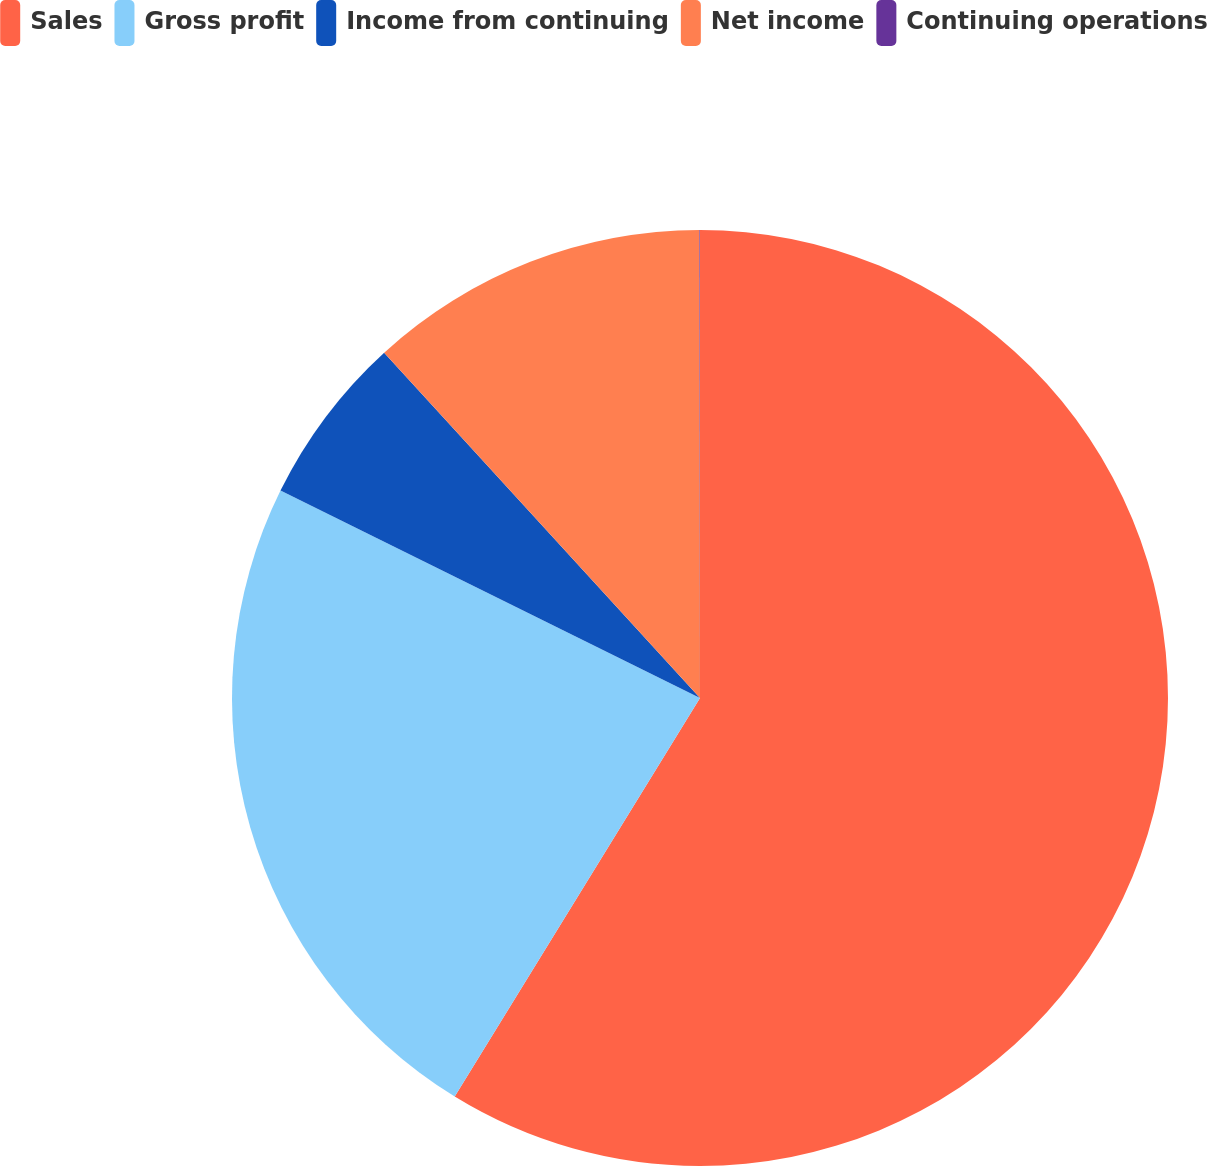<chart> <loc_0><loc_0><loc_500><loc_500><pie_chart><fcel>Sales<fcel>Gross profit<fcel>Income from continuing<fcel>Net income<fcel>Continuing operations<nl><fcel>58.78%<fcel>23.53%<fcel>5.9%<fcel>11.77%<fcel>0.02%<nl></chart> 